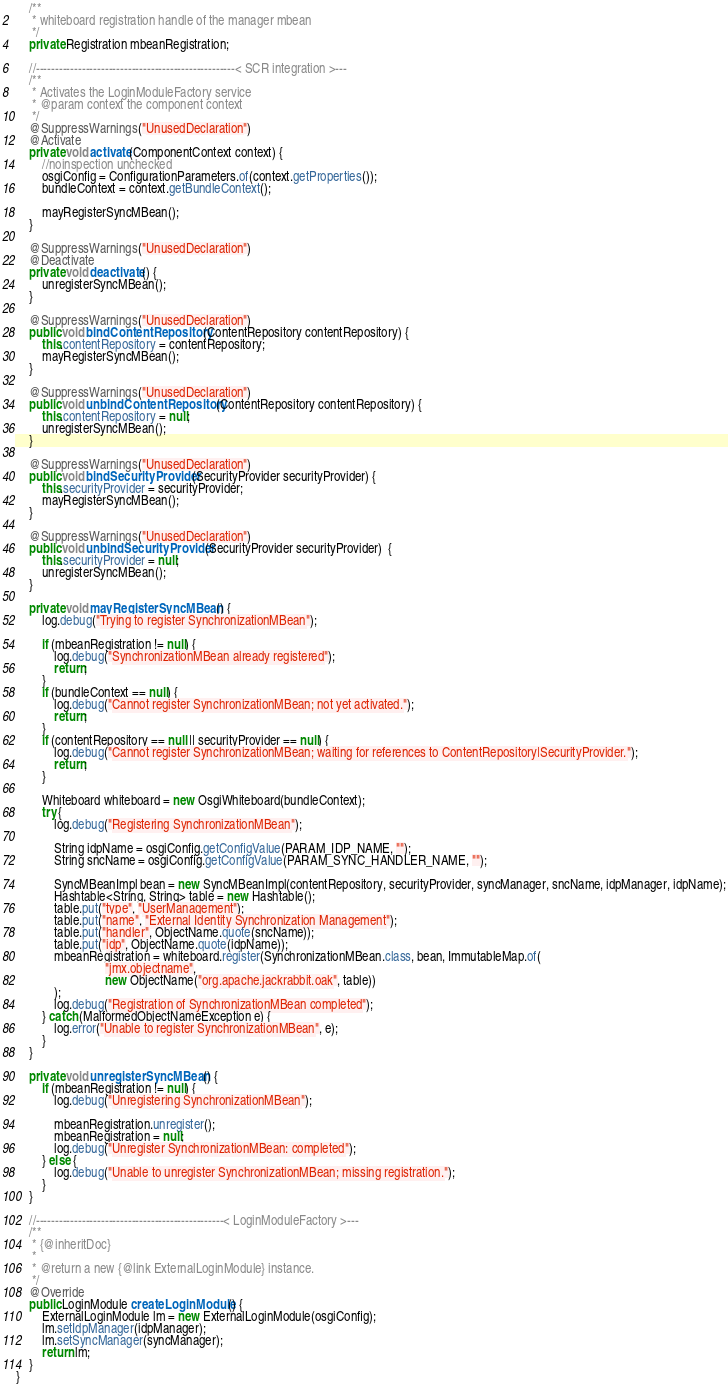Convert code to text. <code><loc_0><loc_0><loc_500><loc_500><_Java_>    /**
     * whiteboard registration handle of the manager mbean
     */
    private Registration mbeanRegistration;

    //----------------------------------------------------< SCR integration >---
    /**
     * Activates the LoginModuleFactory service
     * @param context the component context
     */
    @SuppressWarnings("UnusedDeclaration")
    @Activate
    private void activate(ComponentContext context) {
        //noinspection unchecked
        osgiConfig = ConfigurationParameters.of(context.getProperties());
        bundleContext = context.getBundleContext();

        mayRegisterSyncMBean();
    }

    @SuppressWarnings("UnusedDeclaration")
    @Deactivate
    private void deactivate() {
        unregisterSyncMBean();
    }

    @SuppressWarnings("UnusedDeclaration")
    public void bindContentRepository(ContentRepository contentRepository) {
        this.contentRepository = contentRepository;
        mayRegisterSyncMBean();
    }

    @SuppressWarnings("UnusedDeclaration")
    public void unbindContentRepository(ContentRepository contentRepository) {
        this.contentRepository = null;
        unregisterSyncMBean();
    }

    @SuppressWarnings("UnusedDeclaration")
    public void bindSecurityProvider(SecurityProvider securityProvider) {
        this.securityProvider = securityProvider;
        mayRegisterSyncMBean();
    }

    @SuppressWarnings("UnusedDeclaration")
    public void unbindSecurityProvider(SecurityProvider securityProvider)  {
        this.securityProvider = null;
        unregisterSyncMBean();
    }

    private void mayRegisterSyncMBean() {
        log.debug("Trying to register SynchronizationMBean");

        if (mbeanRegistration != null) {
            log.debug("SynchronizationMBean already registered");
            return;
        }
        if (bundleContext == null) {
            log.debug("Cannot register SynchronizationMBean; not yet activated.");
            return;
        }
        if (contentRepository == null || securityProvider == null) {
            log.debug("Cannot register SynchronizationMBean; waiting for references to ContentRepository|SecurityProvider.");
            return;
        }

        Whiteboard whiteboard = new OsgiWhiteboard(bundleContext);
        try {
            log.debug("Registering SynchronizationMBean");

            String idpName = osgiConfig.getConfigValue(PARAM_IDP_NAME, "");
            String sncName = osgiConfig.getConfigValue(PARAM_SYNC_HANDLER_NAME, "");

            SyncMBeanImpl bean = new SyncMBeanImpl(contentRepository, securityProvider, syncManager, sncName, idpManager, idpName);
            Hashtable<String, String> table = new Hashtable();
            table.put("type", "UserManagement");
            table.put("name", "External Identity Synchronization Management");
            table.put("handler", ObjectName.quote(sncName));
            table.put("idp", ObjectName.quote(idpName));
            mbeanRegistration = whiteboard.register(SynchronizationMBean.class, bean, ImmutableMap.of(
                            "jmx.objectname",
                            new ObjectName("org.apache.jackrabbit.oak", table))
            );
            log.debug("Registration of SynchronizationMBean completed");
        } catch (MalformedObjectNameException e) {
            log.error("Unable to register SynchronizationMBean", e);
        }
    }

    private void unregisterSyncMBean() {
        if (mbeanRegistration != null) {
            log.debug("Unregistering SynchronizationMBean");

            mbeanRegistration.unregister();
            mbeanRegistration = null;
            log.debug("Unregister SynchronizationMBean: completed");
        } else {
            log.debug("Unable to unregister SynchronizationMBean; missing registration.");
        }
    }

    //-------------------------------------------------< LoginModuleFactory >---
    /**
     * {@inheritDoc}
     *
     * @return a new {@link ExternalLoginModule} instance.
     */
    @Override
    public LoginModule createLoginModule() {
        ExternalLoginModule lm = new ExternalLoginModule(osgiConfig);
        lm.setIdpManager(idpManager);
        lm.setSyncManager(syncManager);
        return lm;
    }
}</code> 